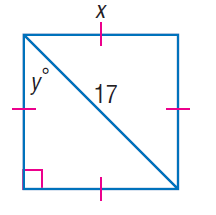Answer the mathemtical geometry problem and directly provide the correct option letter.
Question: Find x.
Choices: A: \frac { 17 \sqrt { 2 } } { 2 } B: 17 C: 17 \sqrt { 2 } D: 34 A 